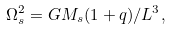Convert formula to latex. <formula><loc_0><loc_0><loc_500><loc_500>\Omega ^ { 2 } _ { s } = G M _ { s } ( 1 + q ) / L ^ { 3 } ,</formula> 